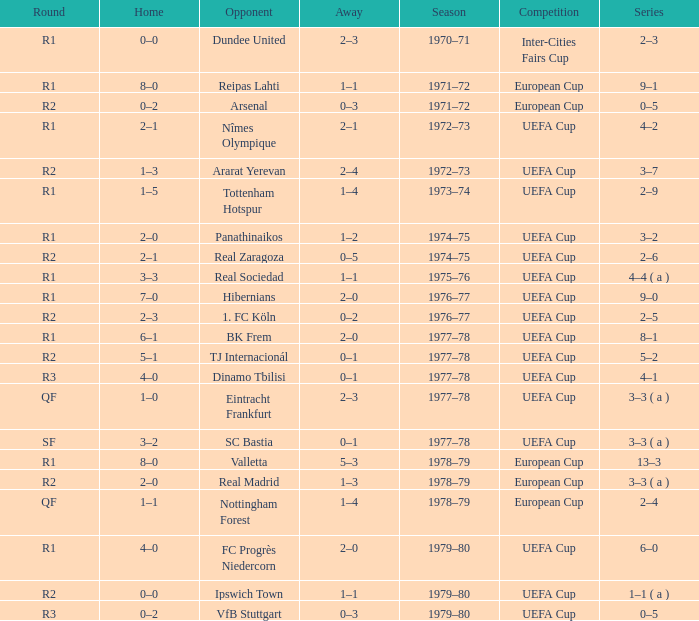Which Season has an Opponent of hibernians? 1976–77. 